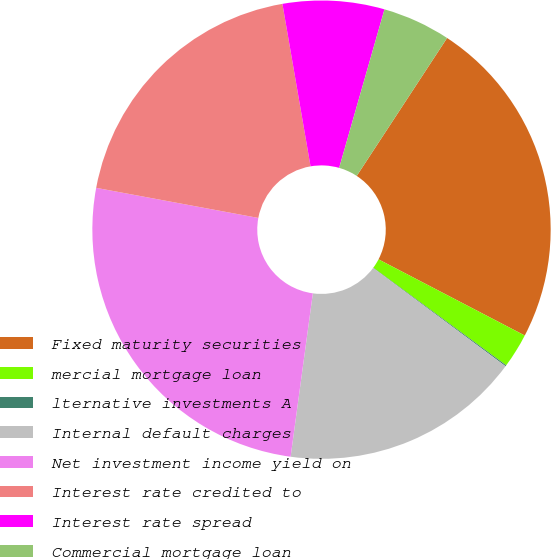Convert chart. <chart><loc_0><loc_0><loc_500><loc_500><pie_chart><fcel>Fixed maturity securities<fcel>mercial mortgage loan<fcel>lternative investments A<fcel>Internal default charges<fcel>Net investment income yield on<fcel>Interest rate credited to<fcel>Interest rate spread<fcel>Commercial mortgage loan<nl><fcel>23.41%<fcel>2.44%<fcel>0.08%<fcel>16.99%<fcel>25.77%<fcel>19.35%<fcel>7.16%<fcel>4.8%<nl></chart> 